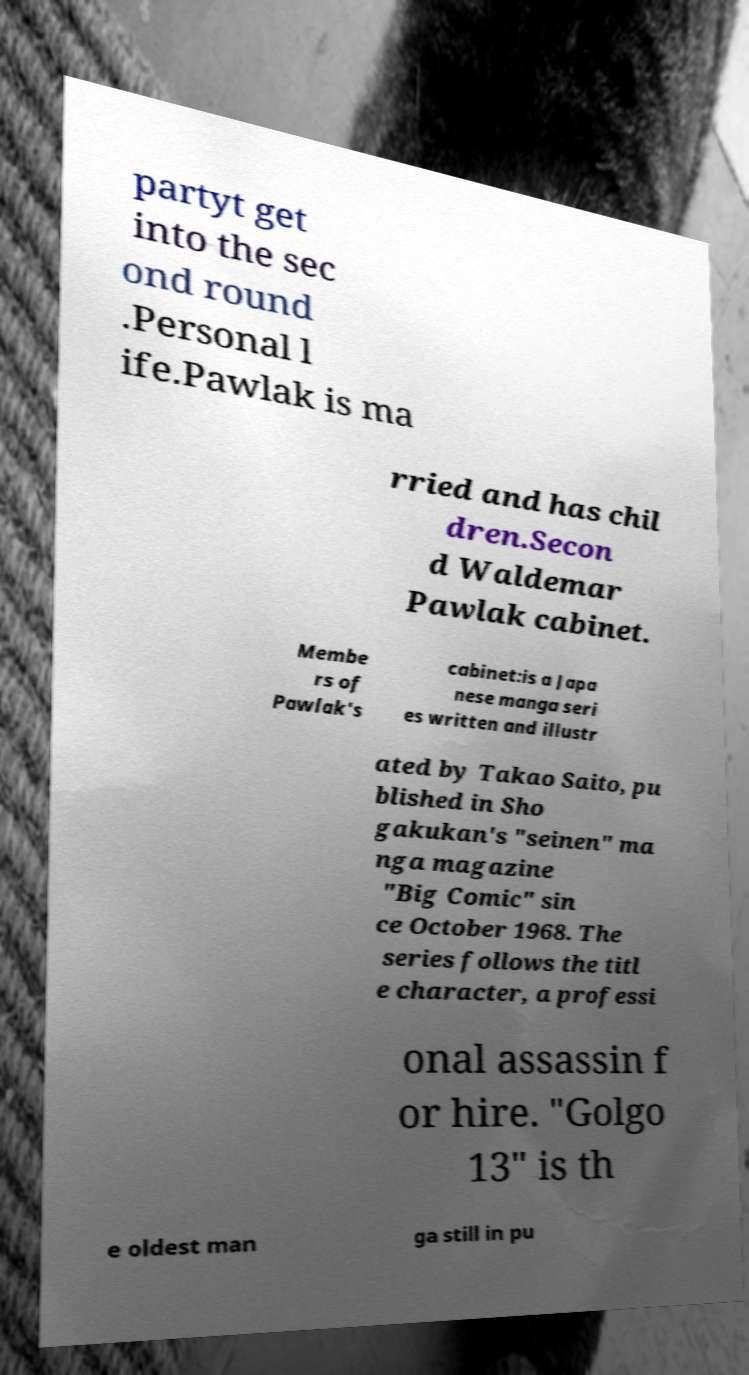What messages or text are displayed in this image? I need them in a readable, typed format. partyt get into the sec ond round .Personal l ife.Pawlak is ma rried and has chil dren.Secon d Waldemar Pawlak cabinet. Membe rs of Pawlak's cabinet:is a Japa nese manga seri es written and illustr ated by Takao Saito, pu blished in Sho gakukan's "seinen" ma nga magazine "Big Comic" sin ce October 1968. The series follows the titl e character, a professi onal assassin f or hire. "Golgo 13" is th e oldest man ga still in pu 